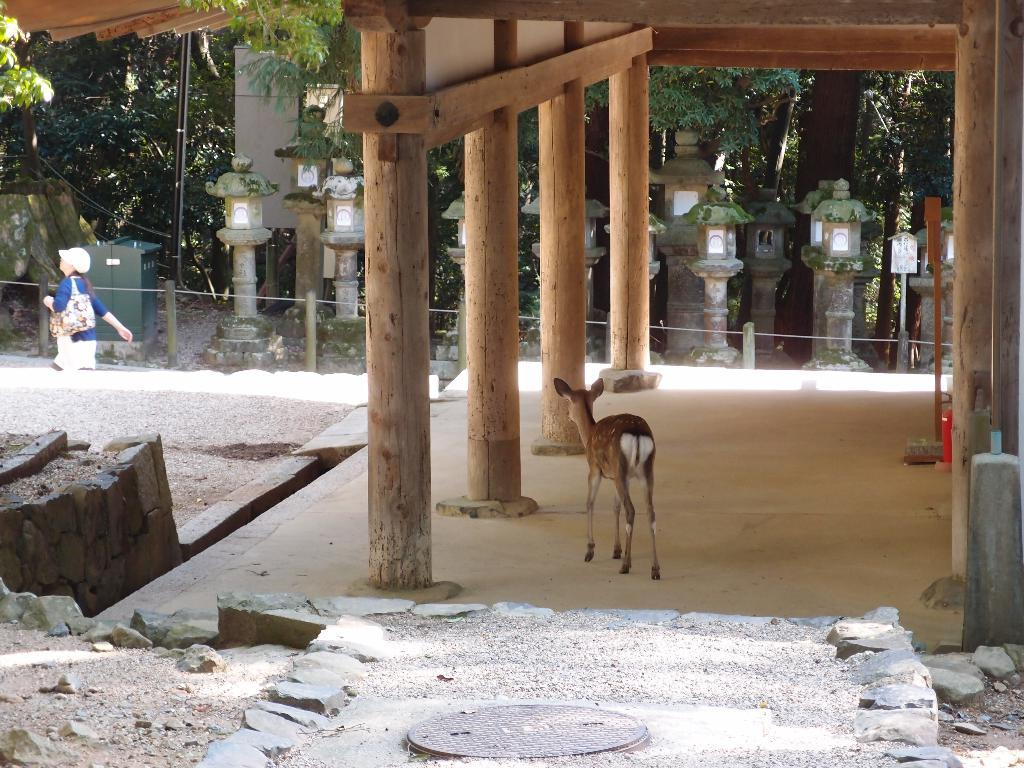What type of structures can be seen in the image? There are pillars in the image. What natural elements are present in the image? There are trees in the image. Is there any wildlife visible in the image? Yes, there is an animal in the image. What type of barrier is present in the image? There is fencing in the image. Can you describe an object with a specific color in the image? There is a green box in the image. What is the person in the image doing? A person is walking in the image. What is the person carrying while walking? The person is wearing a bag. What type of record can be seen in the image? There is no record present in the image. Is there a bear visible in the image? No, there is no bear present in the image. 